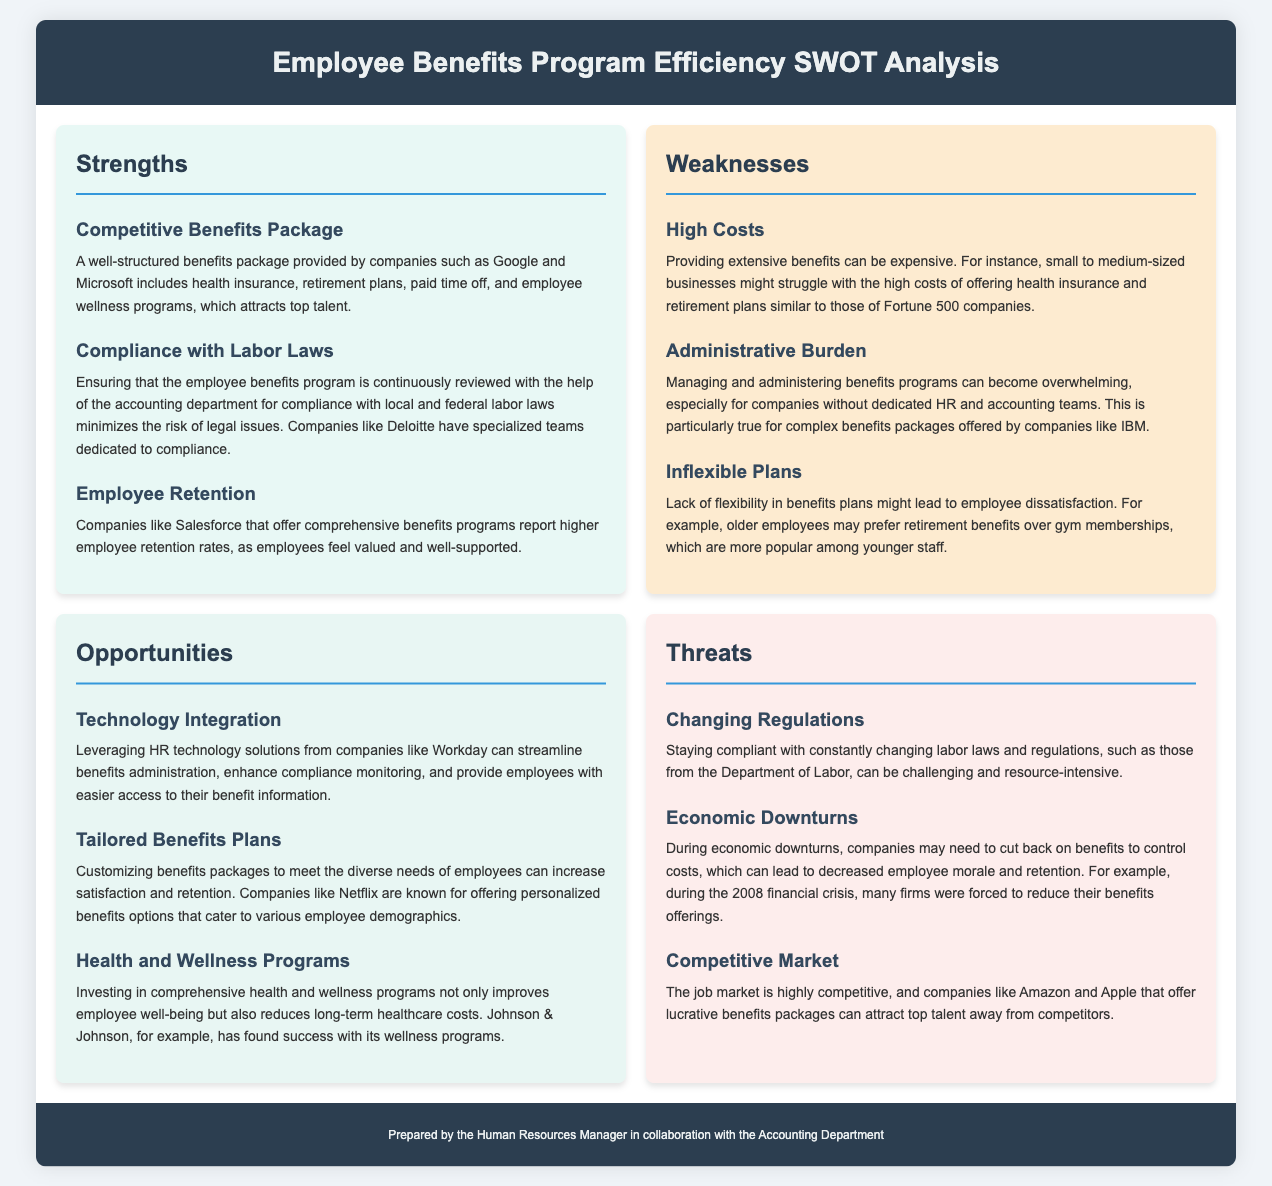What is one strength of the Employee Benefits Program? The strengths section outlines various positive aspects of the program, one of which is a well-structured benefits package.
Answer: Competitive Benefits Package Which company has a specialized team dedicated to compliance? The document mentions Deloitte as an example of a company with a team focused on compliance with labor laws.
Answer: Deloitte What is a potential weakness mentioned related to costs? The weaknesses section describes high expenses involved in offering benefits, specifically for small to medium-sized businesses.
Answer: High Costs How can technology improve the Employee Benefits Program? The opportunities section discusses the use of HR technology solutions to enhance efficiency in benefits administration.
Answer: Technology Integration What is a threat related to economic conditions? The document lists economic downturns as a concern that may affect benefits offerings and employee morale.
Answer: Economic Downturns Which company's benefits program emphasizes tailored options? Netflix is highlighted in the document for customizing benefits packages to meet diverse employee needs.
Answer: Netflix What benefit type is particularly sought after by older employees? The weaknesses section suggests that older employees may prefer retirement benefits over other types offered.
Answer: Retirement Benefits What program has Johnson & Johnson invested in? The opportunities section indicates that Johnson & Johnson has found success with health and wellness programs.
Answer: Health and Wellness Programs 